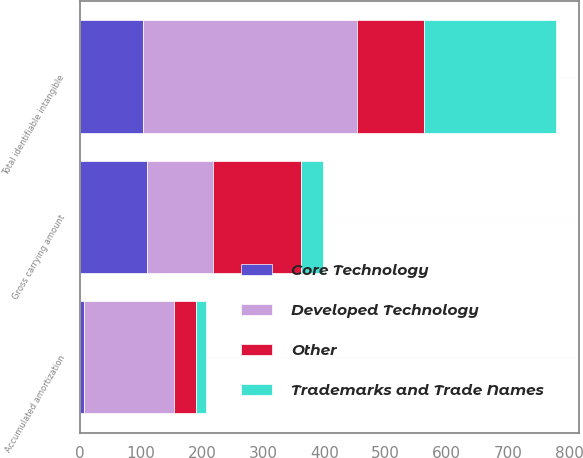<chart> <loc_0><loc_0><loc_500><loc_500><stacked_bar_chart><ecel><fcel>Gross carrying amount<fcel>Accumulated amortization<fcel>Total identifiable intangible<nl><fcel>Other<fcel>144.1<fcel>36<fcel>108.1<nl><fcel>Developed Technology<fcel>108.1<fcel>147.5<fcel>351.3<nl><fcel>Core Technology<fcel>109.4<fcel>6.7<fcel>102.7<nl><fcel>Trademarks and Trade Names<fcel>35.6<fcel>16.6<fcel>216<nl></chart> 